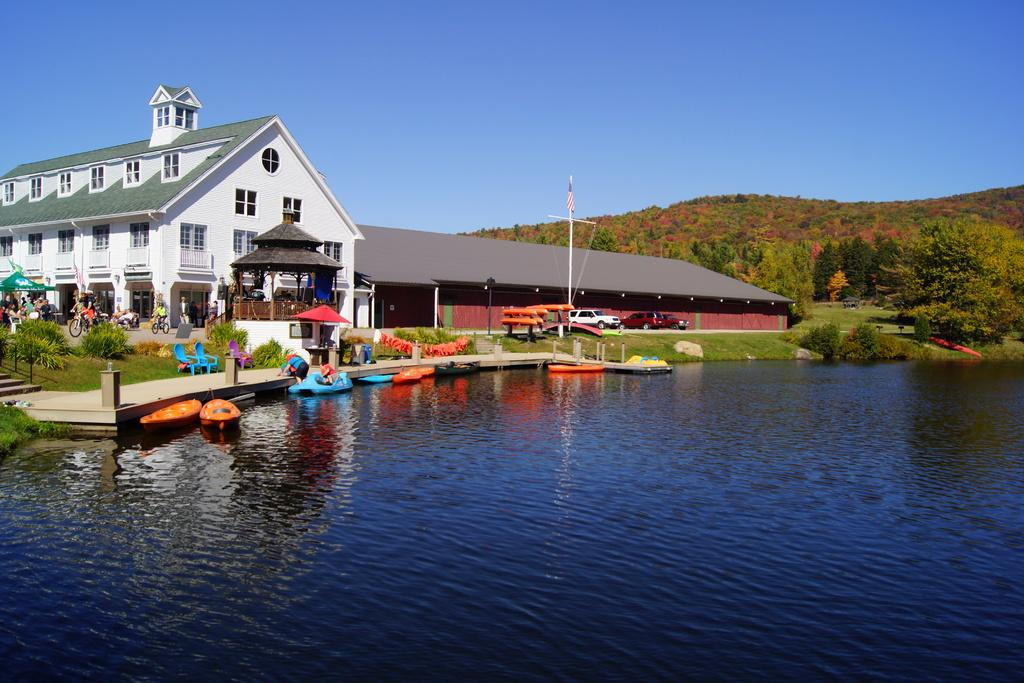What is on the water in the image? There are boats on the water in the image. What can be seen in the background of the image? In the background of the image, there are plants, grass, trees, bicycles, people, and poles. What part of the natural environment is visible in the image? The sky is visible in the image. What type of apparatus is being used by the people in the image? There is no apparatus visible in the image; the people are simply standing or walking in the background. How many cars can be seen in the image? There are no cars present in the image. Is there a balloon visible in the image? There is no balloon present in the image. 